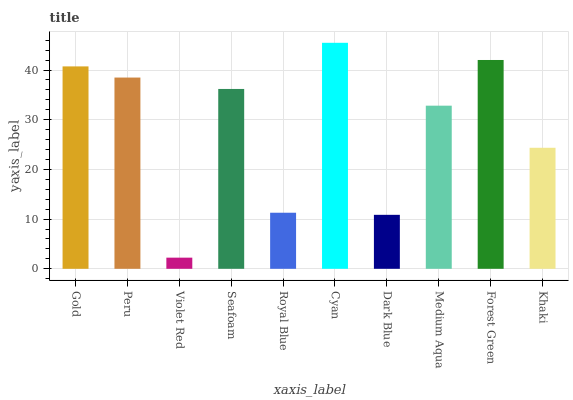Is Violet Red the minimum?
Answer yes or no. Yes. Is Cyan the maximum?
Answer yes or no. Yes. Is Peru the minimum?
Answer yes or no. No. Is Peru the maximum?
Answer yes or no. No. Is Gold greater than Peru?
Answer yes or no. Yes. Is Peru less than Gold?
Answer yes or no. Yes. Is Peru greater than Gold?
Answer yes or no. No. Is Gold less than Peru?
Answer yes or no. No. Is Seafoam the high median?
Answer yes or no. Yes. Is Medium Aqua the low median?
Answer yes or no. Yes. Is Cyan the high median?
Answer yes or no. No. Is Peru the low median?
Answer yes or no. No. 